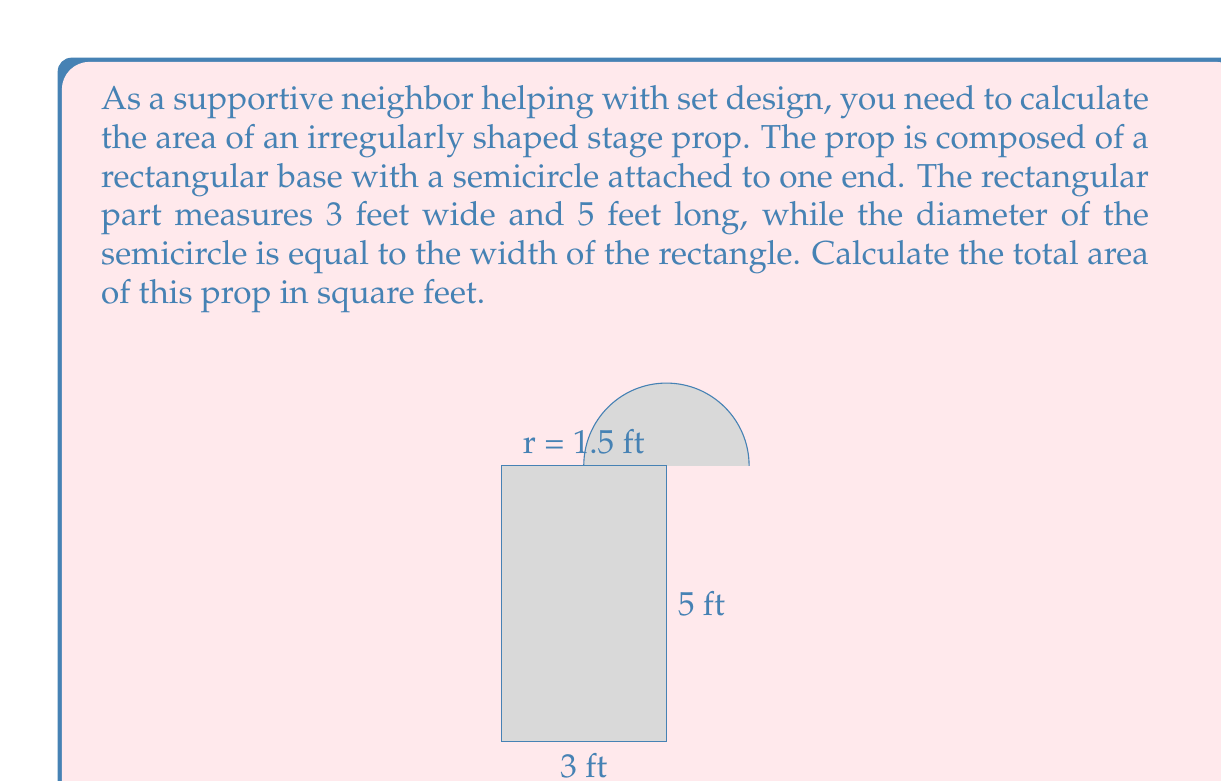Solve this math problem. To solve this problem, we need to calculate the areas of the rectangular part and the semicircular part separately, then add them together.

1. Area of the rectangle:
   $$ A_r = l \times w = 5 \text{ ft} \times 3 \text{ ft} = 15 \text{ sq ft} $$

2. Area of the semicircle:
   The radius of the semicircle is half the width of the rectangle: $r = 3 \text{ ft} \div 2 = 1.5 \text{ ft}$
   The area of a full circle is $\pi r^2$, so the area of a semicircle is half of that:
   $$ A_s = \frac{1}{2} \pi r^2 = \frac{1}{2} \pi (1.5 \text{ ft})^2 = \frac{9\pi}{4} \text{ sq ft} $$

3. Total area:
   $$ A_{total} = A_r + A_s = 15 \text{ sq ft} + \frac{9\pi}{4} \text{ sq ft} $$

4. Simplify:
   $$ A_{total} = 15 + \frac{9\pi}{4} = \frac{60 + 9\pi}{4} \text{ sq ft} $$

5. Calculate the approximate value:
   $$ A_{total} \approx 22.07 \text{ sq ft} $$
Answer: The total area of the irregularly shaped stage prop is $\frac{60 + 9\pi}{4}$ square feet, or approximately 22.07 square feet. 